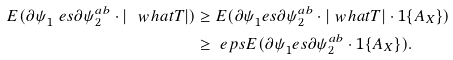Convert formula to latex. <formula><loc_0><loc_0><loc_500><loc_500>E ( \partial \psi _ { 1 } ^ { \ } e s \partial \psi _ { 2 } ^ { a b } \cdot | \ w h a t T | ) & \geq E ( \partial \psi _ { 1 } ^ { \ } e s \partial \psi _ { 2 } ^ { a b } \cdot | \ w h a t T | \cdot 1 \{ A _ { X } \} ) \\ & \geq \ e p s E ( \partial \psi _ { 1 } ^ { \ } e s \partial \psi _ { 2 } ^ { a b } \cdot 1 \{ A _ { X } \} ) .</formula> 